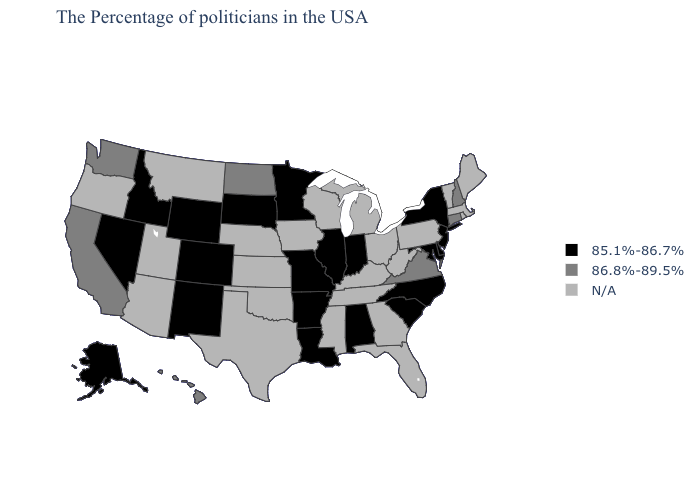Which states hav the highest value in the West?
Give a very brief answer. California, Washington, Hawaii. What is the highest value in the West ?
Concise answer only. 86.8%-89.5%. Does North Dakota have the highest value in the USA?
Concise answer only. Yes. Does California have the lowest value in the USA?
Give a very brief answer. No. Among the states that border Rhode Island , which have the highest value?
Short answer required. Connecticut. What is the value of Iowa?
Short answer required. N/A. How many symbols are there in the legend?
Write a very short answer. 3. Which states have the lowest value in the USA?
Be succinct. New York, New Jersey, Delaware, Maryland, North Carolina, South Carolina, Indiana, Alabama, Illinois, Louisiana, Missouri, Arkansas, Minnesota, South Dakota, Wyoming, Colorado, New Mexico, Idaho, Nevada, Alaska. What is the value of Mississippi?
Give a very brief answer. N/A. Name the states that have a value in the range 85.1%-86.7%?
Keep it brief. New York, New Jersey, Delaware, Maryland, North Carolina, South Carolina, Indiana, Alabama, Illinois, Louisiana, Missouri, Arkansas, Minnesota, South Dakota, Wyoming, Colorado, New Mexico, Idaho, Nevada, Alaska. Which states have the lowest value in the USA?
Short answer required. New York, New Jersey, Delaware, Maryland, North Carolina, South Carolina, Indiana, Alabama, Illinois, Louisiana, Missouri, Arkansas, Minnesota, South Dakota, Wyoming, Colorado, New Mexico, Idaho, Nevada, Alaska. Does the first symbol in the legend represent the smallest category?
Quick response, please. Yes. Does Washington have the lowest value in the USA?
Concise answer only. No. Does Virginia have the highest value in the USA?
Be succinct. Yes. What is the lowest value in the West?
Quick response, please. 85.1%-86.7%. 